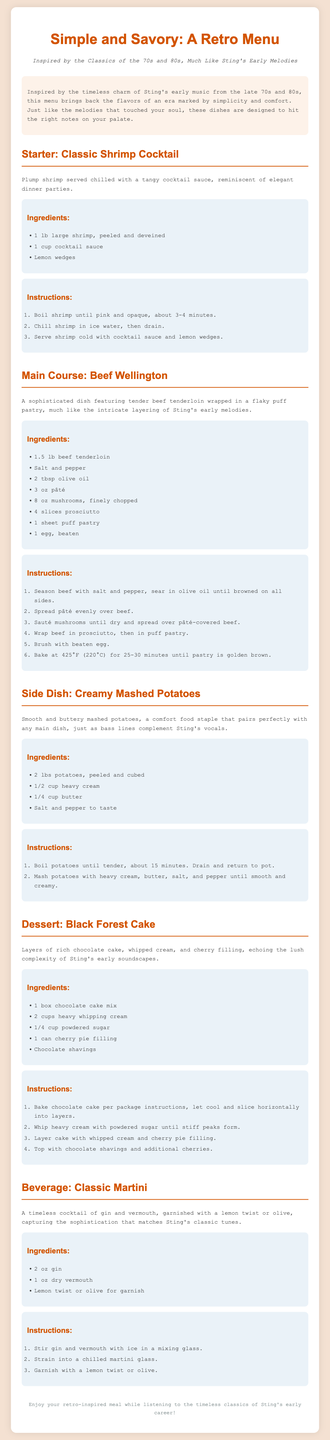What is the title of the menu? The title of the menu is presented prominently at the top of the document.
Answer: Simple and Savory: A Retro Menu What is the main ingredient in Beef Wellington? The main ingredient is listed in the ingredients section for the main course.
Answer: Beef tenderloin How long do you bake the Beef Wellington? The cooking time for the Beef Wellington is specified in the instructions.
Answer: 25-30 minutes What dessert is featured in the menu? The dessert section names the featured dessert in a clear heading.
Answer: Black Forest Cake Which drink pairs with the meal? The beverage section identifies the drink that complements the meal.
Answer: Classic Martini What era inspired this menu? The introduction provides details about the inspiration behind the menu.
Answer: 70s and 80s What texture should the mashed potatoes be? The description in the side dish section implies the desired consistency.
Answer: Smooth and creamy How many ounces of gin are needed for the martini? The ingredients list specifies the amount of gin required for the beverage.
Answer: 2 oz List one ingredient for the shrimp cocktail. The ingredients section for the starter includes several items.
Answer: Cocktail sauce 